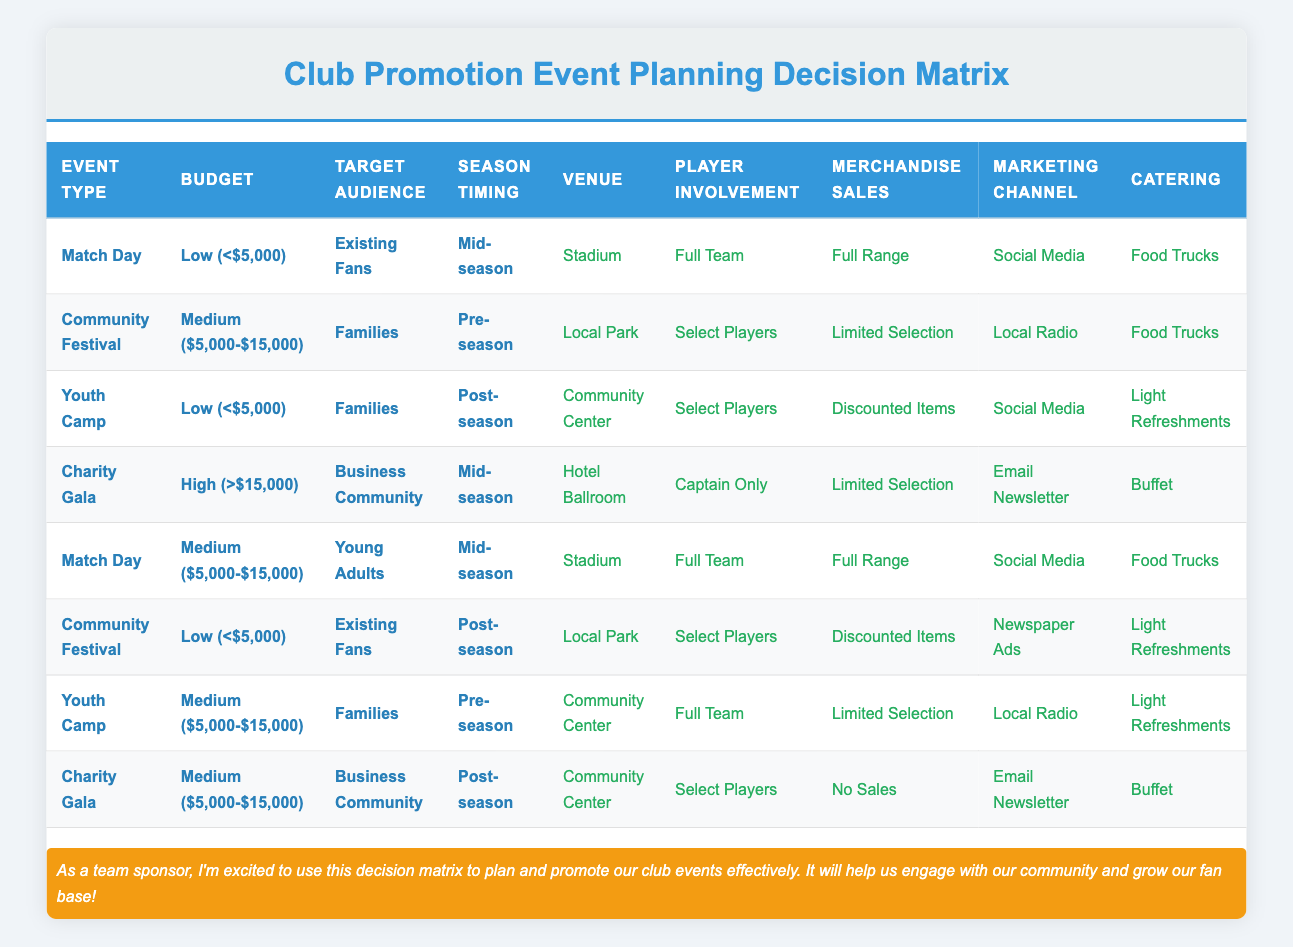What is the venue for the Youth Camp with a low budget targeting Families in the post-season? From the table, we find the row for Youth Camp with the conditions: Low budget, Families as the target audience, and Post-season. The corresponding venue listed in that row is the Community Center.
Answer: Community Center For which event type is the player involvement limited to the Captain only? By examining the table, we can see that the Charity Gala has the player involvement category as Captain Only, while displaying the corresponding conditions: High budget, Business Community as the target audience, and Mid-season.
Answer: Charity Gala Is there a Community Festival event that has discounted merchandise sales? Looking through the table, we find a Community Festival that occurs with a Low budget targeting Existing Fans in the Post-season, which has discounted items for merchandise sales. Thus, the answer is yes.
Answer: Yes What are the total number of events held in the stadium, and what types are they? We check the table for any events held in the stadium. There are two events: Match Day (Low budget for Existing Fans, Mid-season) and Match Day (Medium budget for Young Adults, Mid-season). Thus, the total number is 2, and they are both Match Day events.
Answer: 2, Match Day Which marketing channel is used for the Community Festival when the budget is Medium and the target audience is Families during Pre-season? We look at the row for Community Festival with a Medium budget, targeting Families, and occurring in Pre-season. The marketing channel listed there is Local Radio.
Answer: Local Radio Is it true that any Youth Camp events occur with full team involvement? Checking the table, we see Youth Camp events only appear with Select Players involvement and Full Team involvement occurs in the Medium budget event targeting Families in Pre-season only. Hence, it is false.
Answer: No What venue and catering options are associated with the Charity Gala during the Mid-season? The row for Charity Gala in Mid-season with a High budget and targeting Business Community lists the venue as Hotel Ballroom and catering as Buffet. Thus, we state both elements for clarity.
Answer: Hotel Ballroom, Buffet How many events target Existing Fans, and what are their event types? Reviewing the table for events targeting Existing Fans, we find two events: Match Day (Low budget, Mid-season) and Community Festival (Low budget, Post-season). Thus, there are 2 events targeting Existing Fans.
Answer: 2, Match Day and Community Festival 